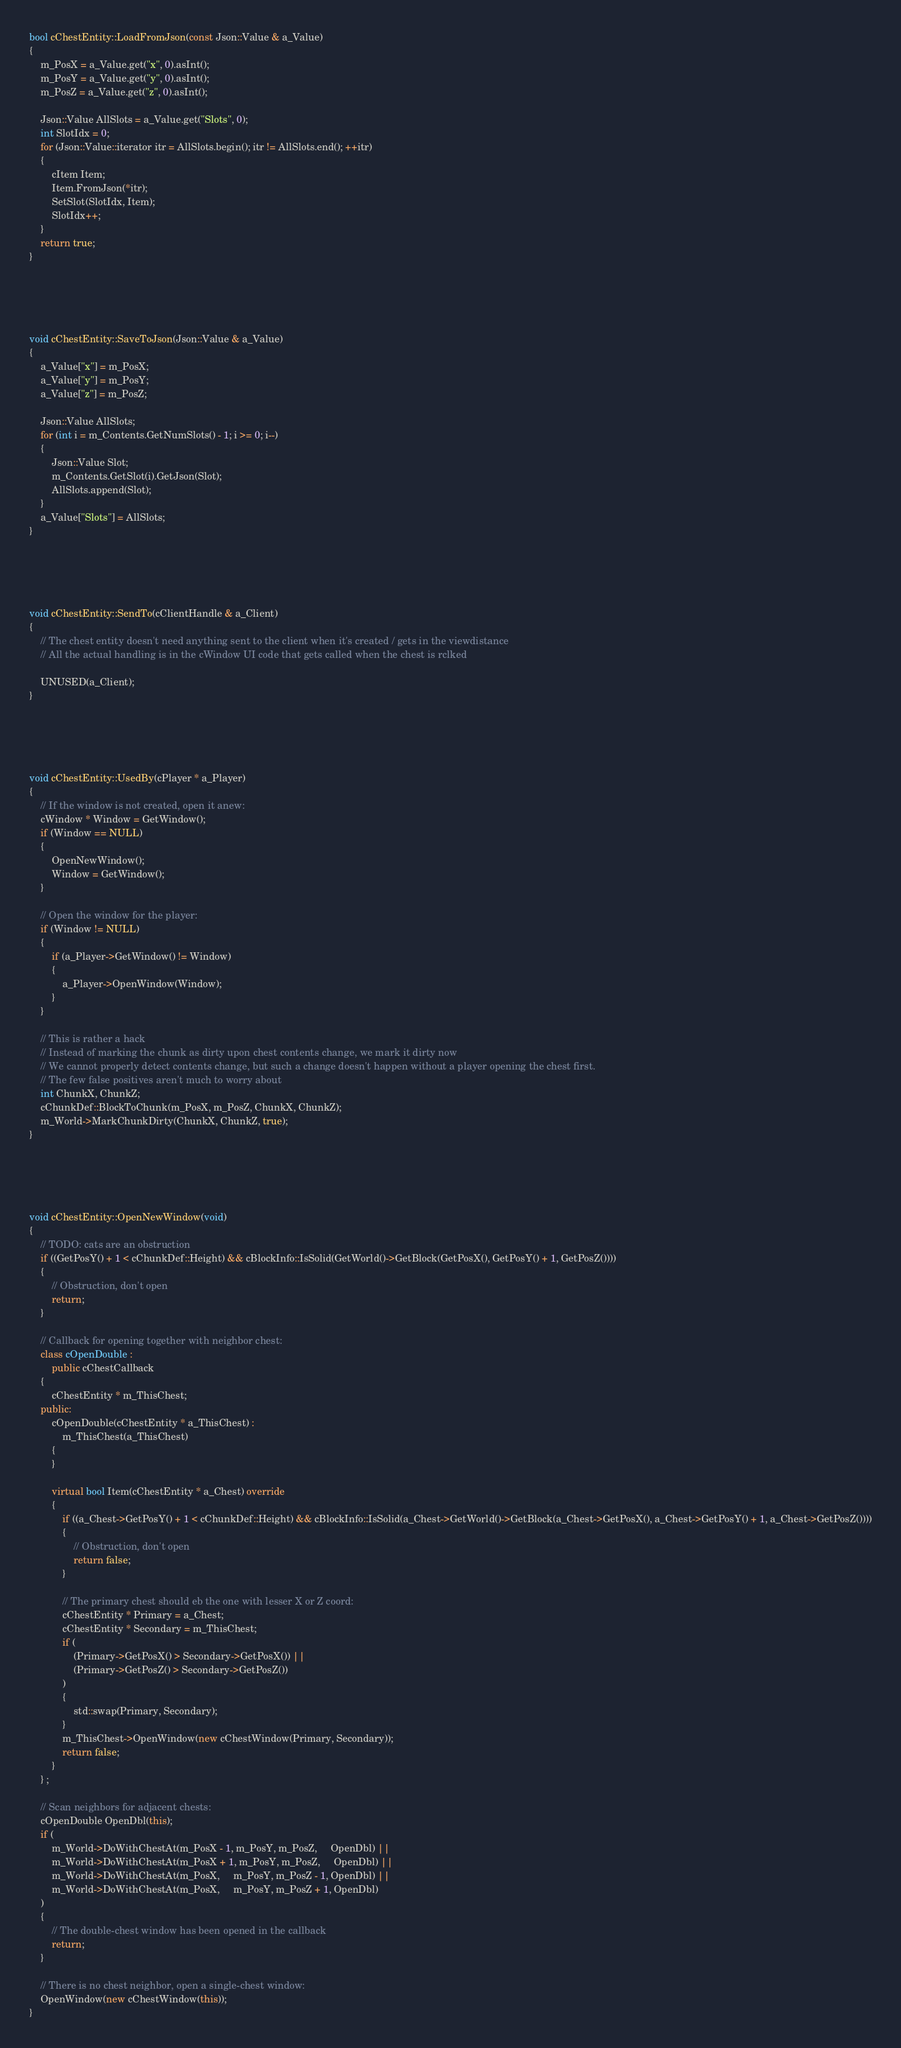Convert code to text. <code><loc_0><loc_0><loc_500><loc_500><_C++_>

bool cChestEntity::LoadFromJson(const Json::Value & a_Value)
{
	m_PosX = a_Value.get("x", 0).asInt();
	m_PosY = a_Value.get("y", 0).asInt();
	m_PosZ = a_Value.get("z", 0).asInt();

	Json::Value AllSlots = a_Value.get("Slots", 0);
	int SlotIdx = 0;
	for (Json::Value::iterator itr = AllSlots.begin(); itr != AllSlots.end(); ++itr)
	{
		cItem Item;
		Item.FromJson(*itr);
		SetSlot(SlotIdx, Item);
		SlotIdx++;
	}
	return true;
}





void cChestEntity::SaveToJson(Json::Value & a_Value)
{
	a_Value["x"] = m_PosX;
	a_Value["y"] = m_PosY;
	a_Value["z"] = m_PosZ;

	Json::Value AllSlots;
	for (int i = m_Contents.GetNumSlots() - 1; i >= 0; i--)
	{
		Json::Value Slot;
		m_Contents.GetSlot(i).GetJson(Slot);
		AllSlots.append(Slot);
	}
	a_Value["Slots"] = AllSlots;
}





void cChestEntity::SendTo(cClientHandle & a_Client)
{
	// The chest entity doesn't need anything sent to the client when it's created / gets in the viewdistance
	// All the actual handling is in the cWindow UI code that gets called when the chest is rclked
	
	UNUSED(a_Client);
}





void cChestEntity::UsedBy(cPlayer * a_Player)
{
	// If the window is not created, open it anew:
	cWindow * Window = GetWindow();
	if (Window == NULL)
	{
		OpenNewWindow();
		Window = GetWindow();
	}
	
	// Open the window for the player:
	if (Window != NULL)
	{
		if (a_Player->GetWindow() != Window)
		{
			a_Player->OpenWindow(Window);
		}
	}

	// This is rather a hack
	// Instead of marking the chunk as dirty upon chest contents change, we mark it dirty now
	// We cannot properly detect contents change, but such a change doesn't happen without a player opening the chest first.
	// The few false positives aren't much to worry about
	int ChunkX, ChunkZ;
	cChunkDef::BlockToChunk(m_PosX, m_PosZ, ChunkX, ChunkZ);
	m_World->MarkChunkDirty(ChunkX, ChunkZ, true);
}





void cChestEntity::OpenNewWindow(void)
{
	// TODO: cats are an obstruction
	if ((GetPosY() + 1 < cChunkDef::Height) && cBlockInfo::IsSolid(GetWorld()->GetBlock(GetPosX(), GetPosY() + 1, GetPosZ())))
	{
		// Obstruction, don't open
		return;
	}

	// Callback for opening together with neighbor chest:
	class cOpenDouble :
		public cChestCallback
	{
		cChestEntity * m_ThisChest;
	public:
		cOpenDouble(cChestEntity * a_ThisChest) :
			m_ThisChest(a_ThisChest)
		{
		}
		
		virtual bool Item(cChestEntity * a_Chest) override
		{
			if ((a_Chest->GetPosY() + 1 < cChunkDef::Height) && cBlockInfo::IsSolid(a_Chest->GetWorld()->GetBlock(a_Chest->GetPosX(), a_Chest->GetPosY() + 1, a_Chest->GetPosZ())))
			{
				// Obstruction, don't open
				return false;
			}

			// The primary chest should eb the one with lesser X or Z coord:
			cChestEntity * Primary = a_Chest;
			cChestEntity * Secondary = m_ThisChest;
			if (
				(Primary->GetPosX() > Secondary->GetPosX()) ||
				(Primary->GetPosZ() > Secondary->GetPosZ())
			)
			{
				std::swap(Primary, Secondary);
			}
			m_ThisChest->OpenWindow(new cChestWindow(Primary, Secondary));
			return false;
		}
	} ;
	
	// Scan neighbors for adjacent chests:
	cOpenDouble OpenDbl(this);
	if (
		m_World->DoWithChestAt(m_PosX - 1, m_PosY, m_PosZ,     OpenDbl) ||
		m_World->DoWithChestAt(m_PosX + 1, m_PosY, m_PosZ,     OpenDbl) ||
		m_World->DoWithChestAt(m_PosX,     m_PosY, m_PosZ - 1, OpenDbl) ||
		m_World->DoWithChestAt(m_PosX,     m_PosY, m_PosZ + 1, OpenDbl)
	)
	{
		// The double-chest window has been opened in the callback
		return;
	}

	// There is no chest neighbor, open a single-chest window:
	OpenWindow(new cChestWindow(this));
}




</code> 